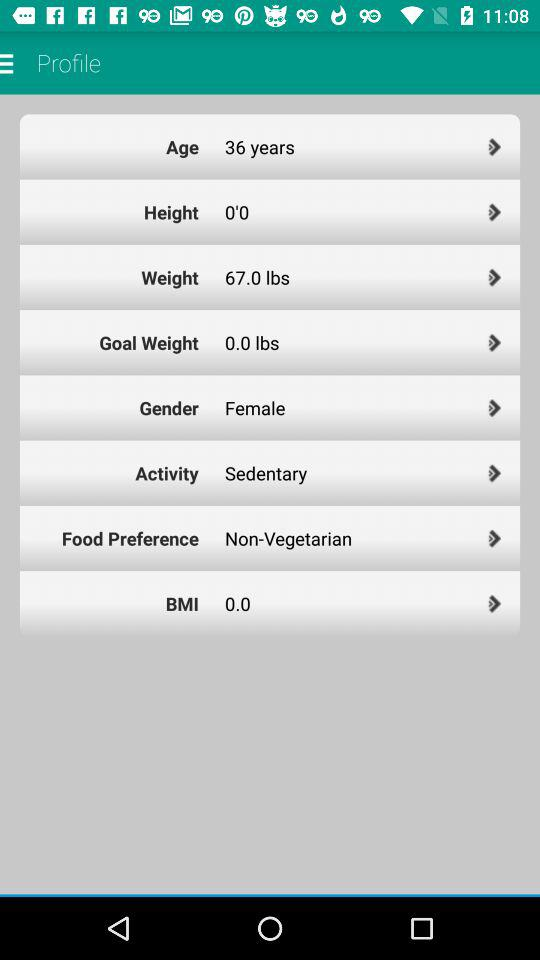Which type of activity is selected? The selected type of activity is "Sedentary". 